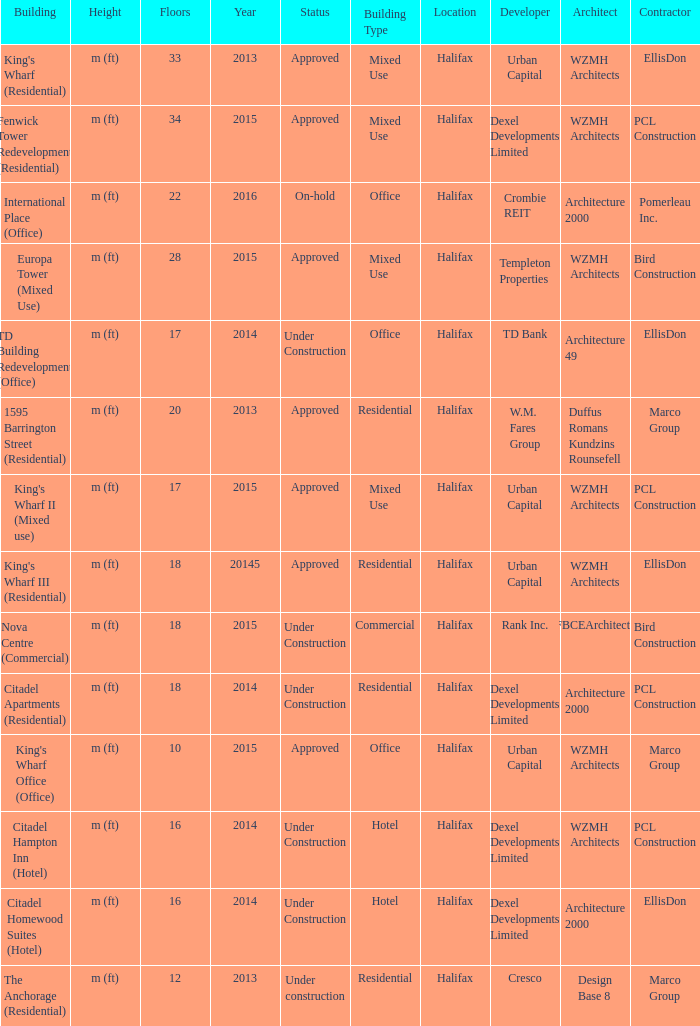What is the status of the building for 2014 with 33 floors? Approved. 